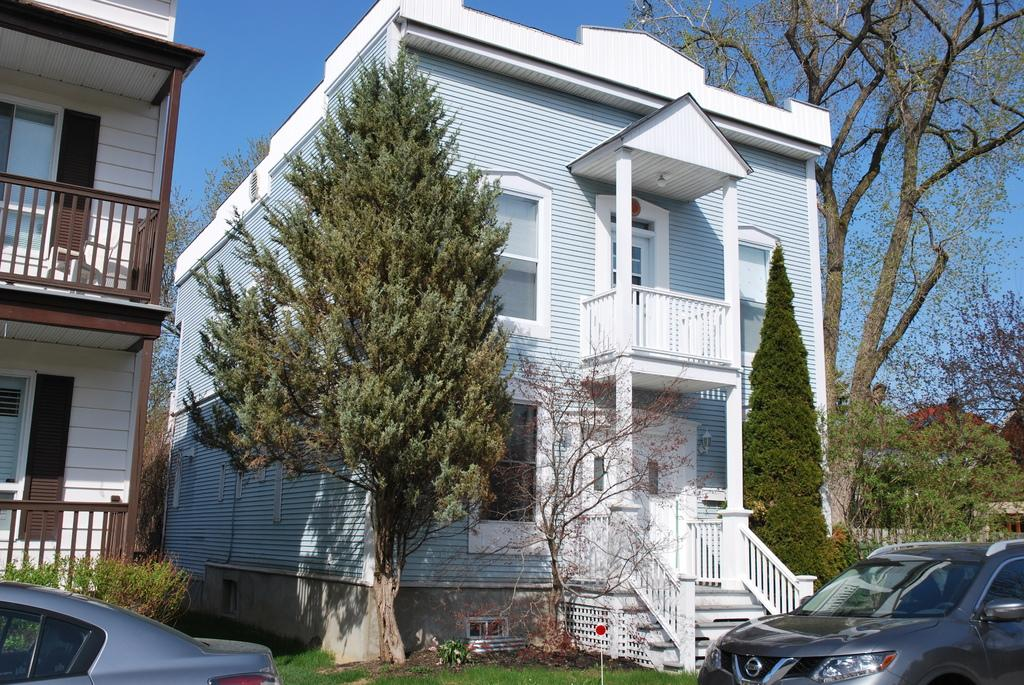What type of plant can be seen in the image? There is a tree in the image. What is the color of the tree? The tree is white. What type of structure is also visible in the image? There is a building in the image. What is the color of the building? The building is white. What type of vehicles are parked in the image? There are two cars parked in the image. What type of vegetation is at the bottom of the image? There is green grass at the bottom of the image. How many trees are visible to the right of the image? There are many trees to the right of the image. What type of collar can be seen on the tree in the image? There is no collar present on the tree in the image. What type of toys are visible in the image? There are no toys visible in the image. 